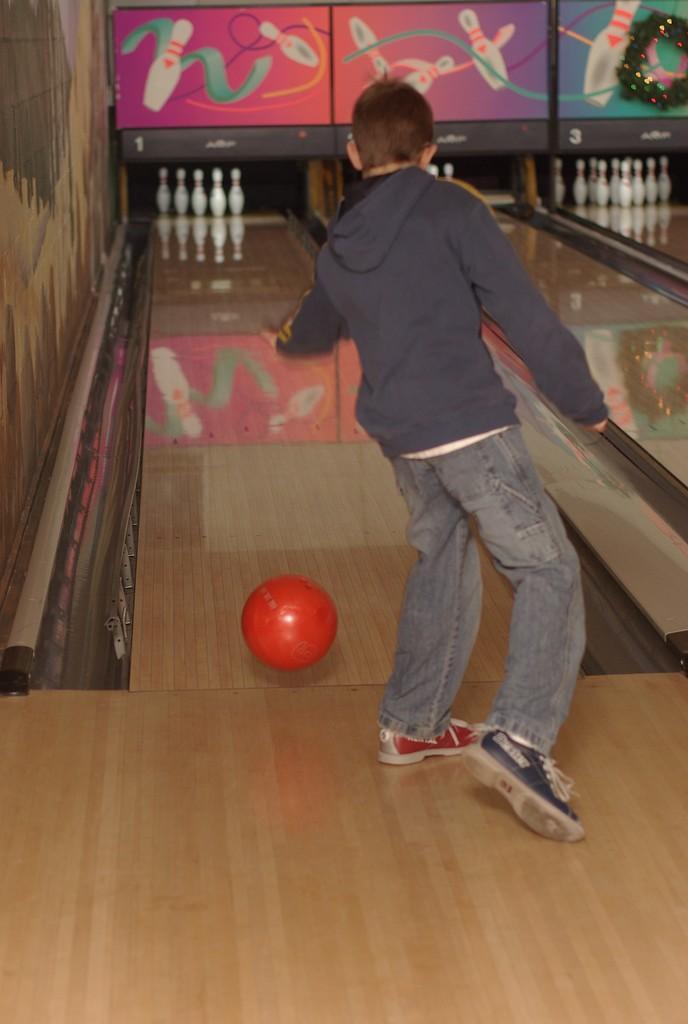Could you give a brief overview of what you see in this image? In this picture I can see a person standing in front of the ball, bowling pins and some boards. 